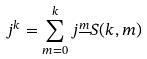<formula> <loc_0><loc_0><loc_500><loc_500>j ^ { k } = \sum _ { m = 0 } ^ { k } j ^ { \underline { m } } S ( k , m )</formula> 